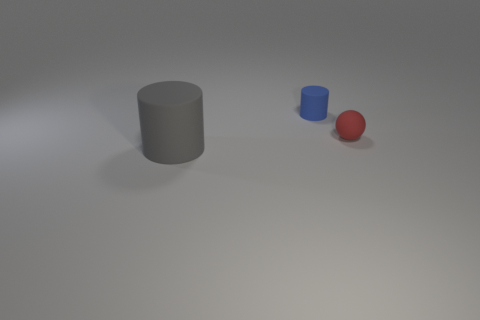Does the cylinder that is in front of the blue object have the same size as the red ball?
Your answer should be very brief. No. What is the material of the cylinder in front of the small red ball?
Ensure brevity in your answer.  Rubber. Is the number of red spheres greater than the number of yellow metallic objects?
Your response must be concise. Yes. What number of things are either rubber objects to the left of the red ball or red matte things?
Offer a very short reply. 3. There is a cylinder right of the big rubber cylinder; how many tiny red balls are on the left side of it?
Offer a terse response. 0. There is a rubber cylinder to the right of the cylinder in front of the small object left of the red sphere; what is its size?
Offer a terse response. Small. There is a gray rubber object that is the same shape as the small blue matte object; what is its size?
Your answer should be compact. Large. What number of objects are matte cylinders behind the big gray matte object or small matte things on the left side of the small rubber sphere?
Your response must be concise. 1. There is a small thing that is left of the rubber thing right of the small blue cylinder; what is its shape?
Provide a short and direct response. Cylinder. Are there any other things that are the same size as the gray matte object?
Make the answer very short. No. 